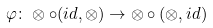<formula> <loc_0><loc_0><loc_500><loc_500>\varphi \colon \otimes \circ ( i d , \otimes ) \rightarrow \otimes \circ ( \otimes , i d )</formula> 